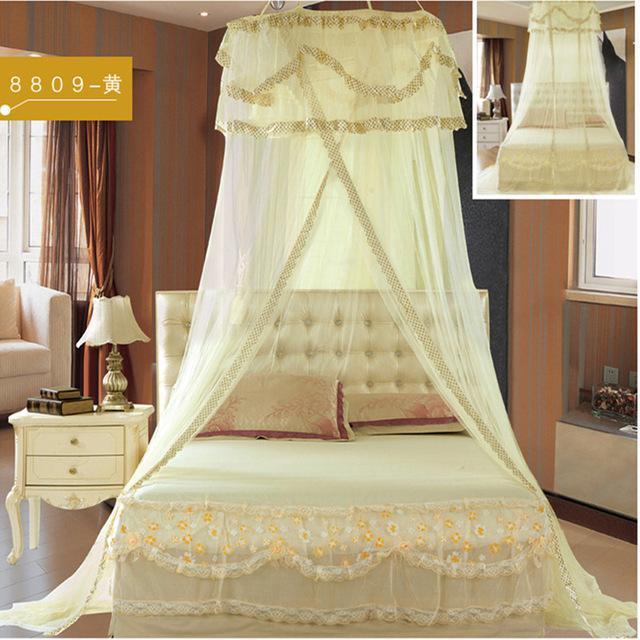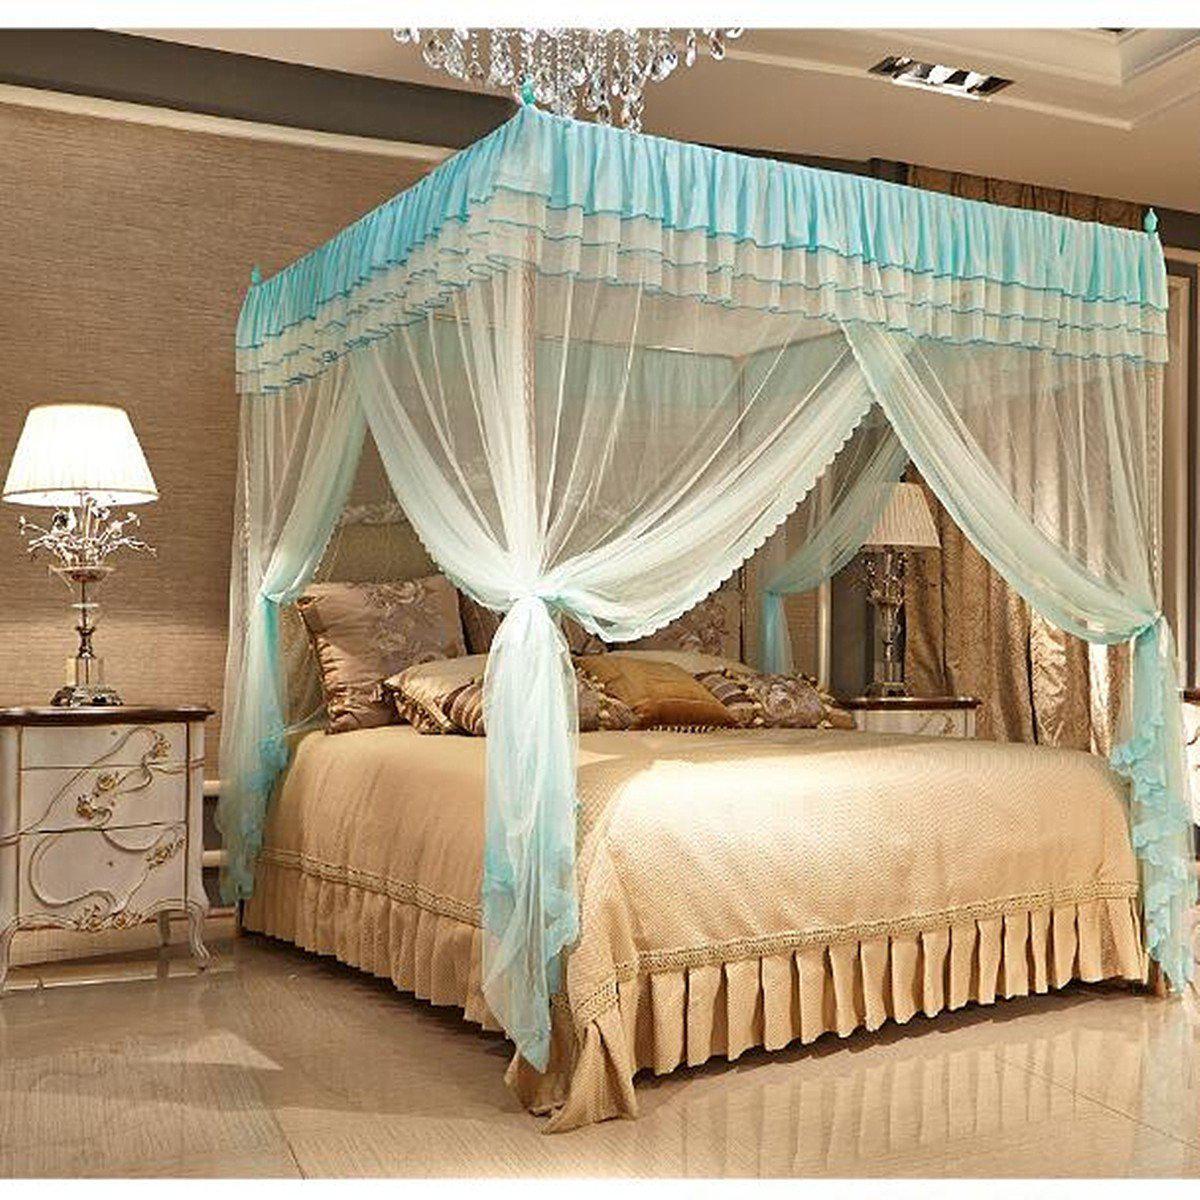The first image is the image on the left, the second image is the image on the right. Given the left and right images, does the statement "The netting in the right image is white." hold true? Answer yes or no. No. The first image is the image on the left, the second image is the image on the right. Evaluate the accuracy of this statement regarding the images: "The right image shows a non-white canopy.". Is it true? Answer yes or no. Yes. 